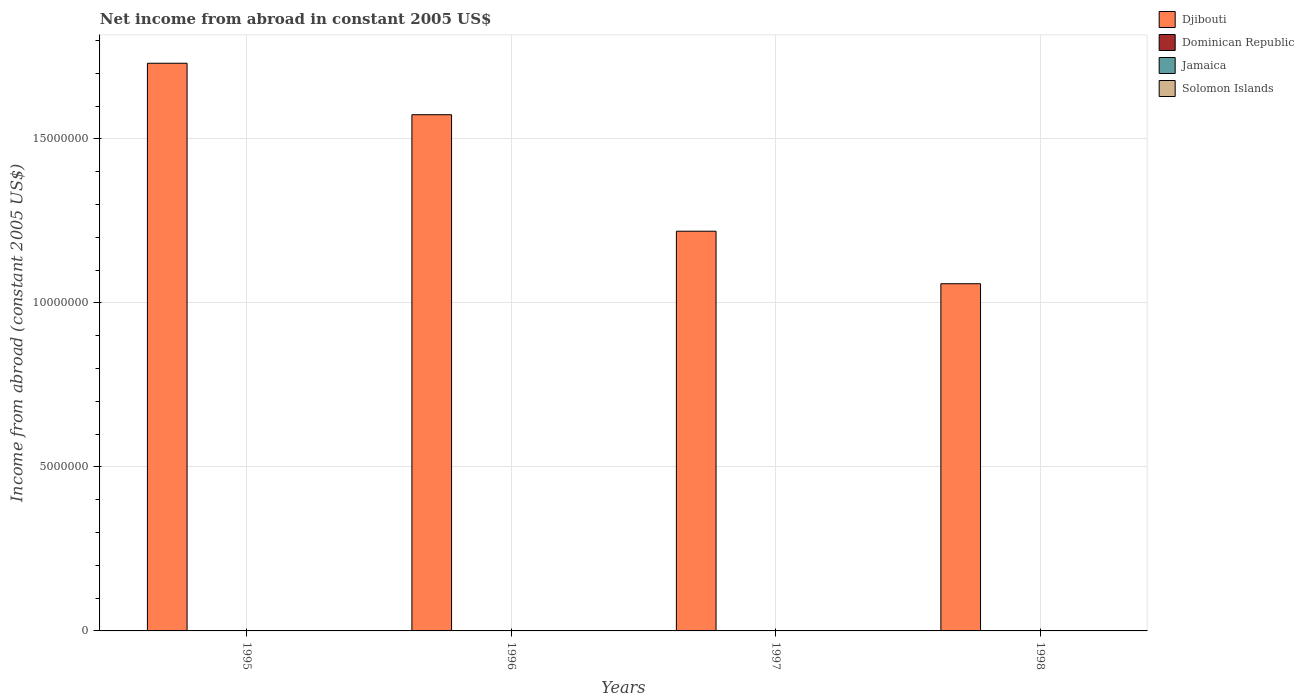Are the number of bars per tick equal to the number of legend labels?
Provide a short and direct response. No. Are the number of bars on each tick of the X-axis equal?
Offer a terse response. Yes. How many bars are there on the 2nd tick from the right?
Your answer should be very brief. 1. In how many cases, is the number of bars for a given year not equal to the number of legend labels?
Provide a short and direct response. 4. Across all years, what is the maximum net income from abroad in Djibouti?
Make the answer very short. 1.73e+07. Across all years, what is the minimum net income from abroad in Djibouti?
Offer a terse response. 1.06e+07. In which year was the net income from abroad in Djibouti maximum?
Your response must be concise. 1995. What is the total net income from abroad in Dominican Republic in the graph?
Your answer should be compact. 0. What is the difference between the net income from abroad in Djibouti in 1995 and that in 1998?
Provide a succinct answer. 6.72e+06. What is the difference between the net income from abroad in Jamaica in 1997 and the net income from abroad in Dominican Republic in 1996?
Provide a short and direct response. 0. What is the average net income from abroad in Djibouti per year?
Your answer should be very brief. 1.40e+07. In how many years, is the net income from abroad in Djibouti greater than 14000000 US$?
Give a very brief answer. 2. What is the ratio of the net income from abroad in Djibouti in 1996 to that in 1998?
Your answer should be very brief. 1.49. What is the difference between the highest and the lowest net income from abroad in Djibouti?
Provide a succinct answer. 6.72e+06. In how many years, is the net income from abroad in Jamaica greater than the average net income from abroad in Jamaica taken over all years?
Your response must be concise. 0. Is the sum of the net income from abroad in Djibouti in 1997 and 1998 greater than the maximum net income from abroad in Jamaica across all years?
Offer a very short reply. Yes. Is it the case that in every year, the sum of the net income from abroad in Djibouti and net income from abroad in Jamaica is greater than the sum of net income from abroad in Dominican Republic and net income from abroad in Solomon Islands?
Make the answer very short. Yes. Is it the case that in every year, the sum of the net income from abroad in Djibouti and net income from abroad in Solomon Islands is greater than the net income from abroad in Dominican Republic?
Keep it short and to the point. Yes. How many bars are there?
Provide a succinct answer. 4. How many years are there in the graph?
Keep it short and to the point. 4. What is the difference between two consecutive major ticks on the Y-axis?
Your response must be concise. 5.00e+06. Does the graph contain any zero values?
Offer a very short reply. Yes. Where does the legend appear in the graph?
Ensure brevity in your answer.  Top right. How are the legend labels stacked?
Keep it short and to the point. Vertical. What is the title of the graph?
Offer a terse response. Net income from abroad in constant 2005 US$. Does "Turkey" appear as one of the legend labels in the graph?
Ensure brevity in your answer.  No. What is the label or title of the Y-axis?
Your response must be concise. Income from abroad (constant 2005 US$). What is the Income from abroad (constant 2005 US$) in Djibouti in 1995?
Make the answer very short. 1.73e+07. What is the Income from abroad (constant 2005 US$) in Jamaica in 1995?
Your answer should be very brief. 0. What is the Income from abroad (constant 2005 US$) in Djibouti in 1996?
Ensure brevity in your answer.  1.57e+07. What is the Income from abroad (constant 2005 US$) in Dominican Republic in 1996?
Keep it short and to the point. 0. What is the Income from abroad (constant 2005 US$) of Djibouti in 1997?
Ensure brevity in your answer.  1.22e+07. What is the Income from abroad (constant 2005 US$) of Dominican Republic in 1997?
Make the answer very short. 0. What is the Income from abroad (constant 2005 US$) in Djibouti in 1998?
Make the answer very short. 1.06e+07. What is the Income from abroad (constant 2005 US$) of Dominican Republic in 1998?
Ensure brevity in your answer.  0. What is the Income from abroad (constant 2005 US$) in Jamaica in 1998?
Your answer should be very brief. 0. Across all years, what is the maximum Income from abroad (constant 2005 US$) in Djibouti?
Ensure brevity in your answer.  1.73e+07. Across all years, what is the minimum Income from abroad (constant 2005 US$) of Djibouti?
Offer a terse response. 1.06e+07. What is the total Income from abroad (constant 2005 US$) of Djibouti in the graph?
Give a very brief answer. 5.58e+07. What is the total Income from abroad (constant 2005 US$) of Solomon Islands in the graph?
Offer a very short reply. 0. What is the difference between the Income from abroad (constant 2005 US$) in Djibouti in 1995 and that in 1996?
Provide a succinct answer. 1.57e+06. What is the difference between the Income from abroad (constant 2005 US$) of Djibouti in 1995 and that in 1997?
Your response must be concise. 5.12e+06. What is the difference between the Income from abroad (constant 2005 US$) of Djibouti in 1995 and that in 1998?
Ensure brevity in your answer.  6.72e+06. What is the difference between the Income from abroad (constant 2005 US$) of Djibouti in 1996 and that in 1997?
Your answer should be very brief. 3.55e+06. What is the difference between the Income from abroad (constant 2005 US$) in Djibouti in 1996 and that in 1998?
Your answer should be very brief. 5.15e+06. What is the difference between the Income from abroad (constant 2005 US$) in Djibouti in 1997 and that in 1998?
Keep it short and to the point. 1.60e+06. What is the average Income from abroad (constant 2005 US$) of Djibouti per year?
Provide a succinct answer. 1.40e+07. What is the average Income from abroad (constant 2005 US$) in Dominican Republic per year?
Offer a very short reply. 0. What is the ratio of the Income from abroad (constant 2005 US$) of Djibouti in 1995 to that in 1996?
Keep it short and to the point. 1.1. What is the ratio of the Income from abroad (constant 2005 US$) in Djibouti in 1995 to that in 1997?
Keep it short and to the point. 1.42. What is the ratio of the Income from abroad (constant 2005 US$) in Djibouti in 1995 to that in 1998?
Keep it short and to the point. 1.64. What is the ratio of the Income from abroad (constant 2005 US$) in Djibouti in 1996 to that in 1997?
Your answer should be very brief. 1.29. What is the ratio of the Income from abroad (constant 2005 US$) in Djibouti in 1996 to that in 1998?
Give a very brief answer. 1.49. What is the ratio of the Income from abroad (constant 2005 US$) in Djibouti in 1997 to that in 1998?
Offer a very short reply. 1.15. What is the difference between the highest and the second highest Income from abroad (constant 2005 US$) of Djibouti?
Make the answer very short. 1.57e+06. What is the difference between the highest and the lowest Income from abroad (constant 2005 US$) of Djibouti?
Provide a succinct answer. 6.72e+06. 